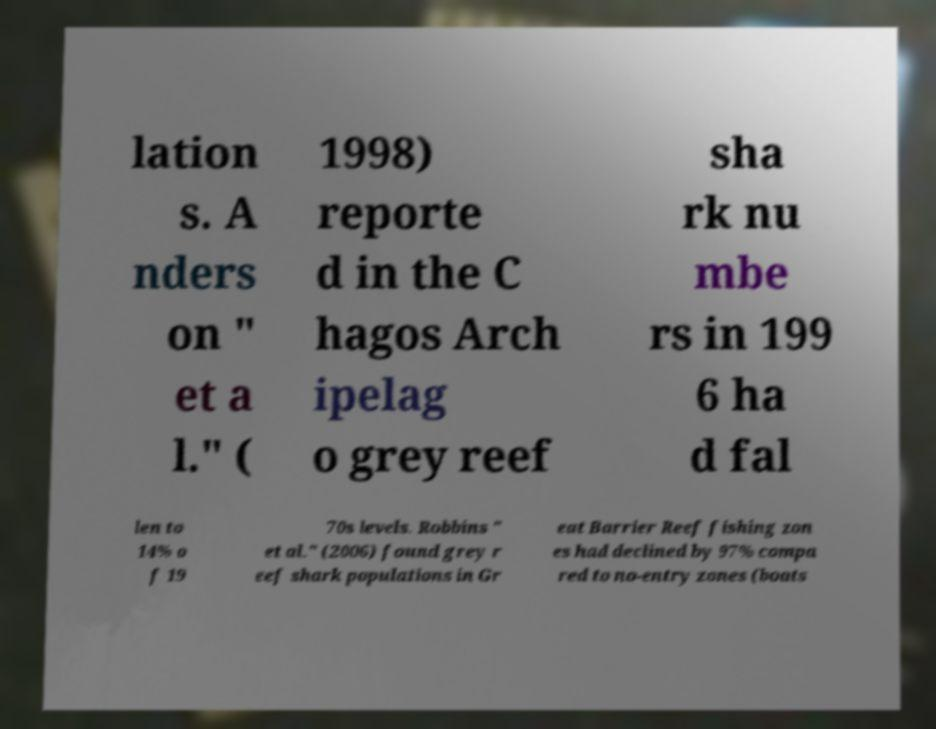Please identify and transcribe the text found in this image. lation s. A nders on " et a l." ( 1998) reporte d in the C hagos Arch ipelag o grey reef sha rk nu mbe rs in 199 6 ha d fal len to 14% o f 19 70s levels. Robbins " et al." (2006) found grey r eef shark populations in Gr eat Barrier Reef fishing zon es had declined by 97% compa red to no-entry zones (boats 